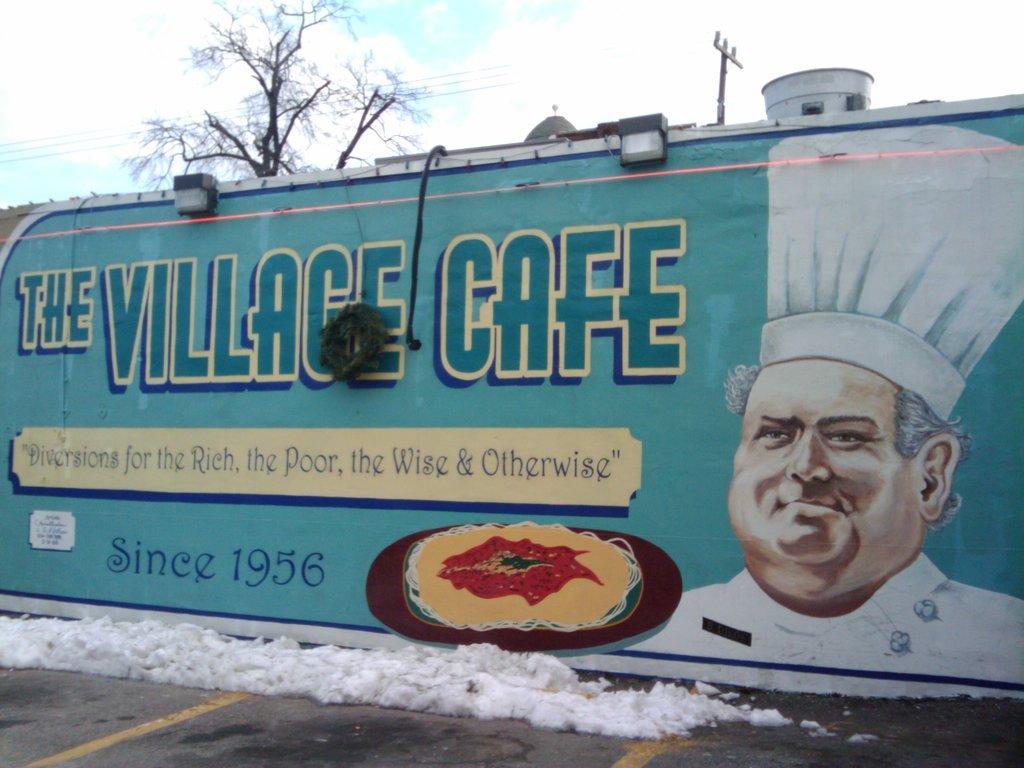Please provide a concise description of this image. In this picture, there is a wall with text and a painting. Towards the right, there is a painting of a man wearing white clothes and a white cap. At the bottom, there is a road with snow. On the top, there is a sky and a tree. 